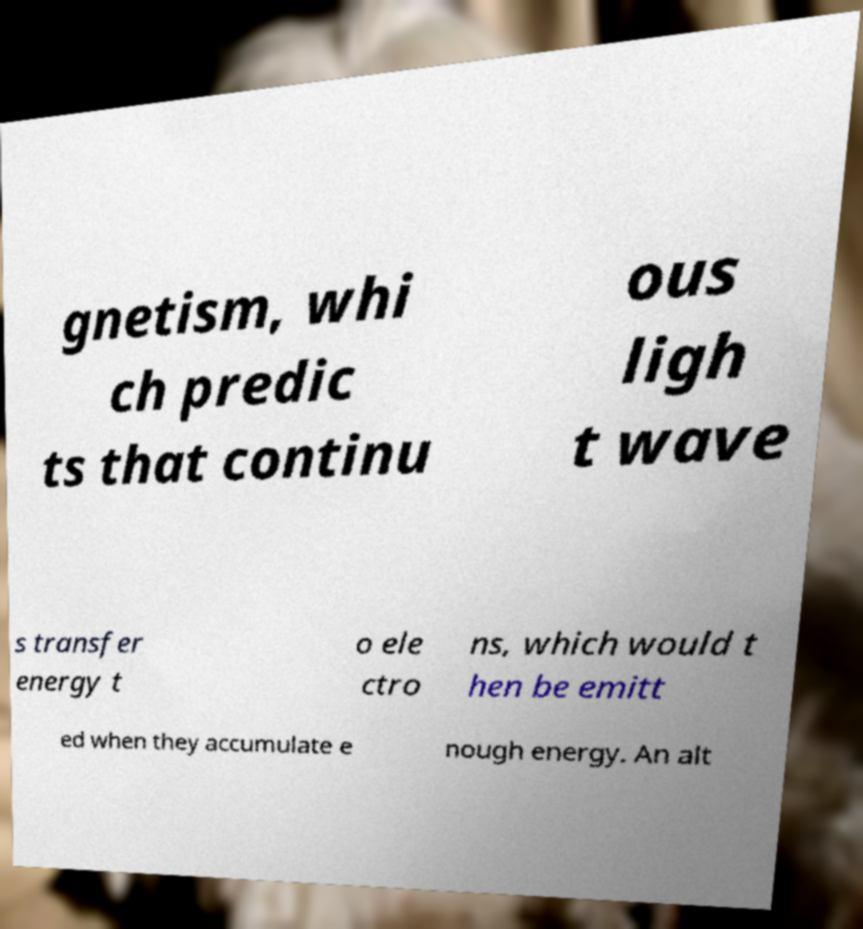Could you extract and type out the text from this image? gnetism, whi ch predic ts that continu ous ligh t wave s transfer energy t o ele ctro ns, which would t hen be emitt ed when they accumulate e nough energy. An alt 